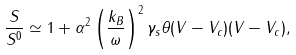Convert formula to latex. <formula><loc_0><loc_0><loc_500><loc_500>\frac { S } { S ^ { 0 } } \simeq 1 + \alpha ^ { 2 } \left ( \frac { k _ { B } } { \omega } \right ) ^ { 2 } \gamma _ { s } \theta ( V - V _ { c } ) ( V - V _ { c } ) ,</formula> 